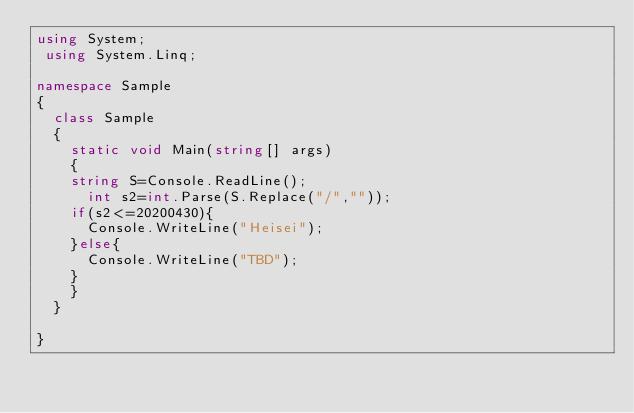Convert code to text. <code><loc_0><loc_0><loc_500><loc_500><_C#_>using System;
 using System.Linq;

namespace Sample
{
  class Sample
  {
    static void Main(string[] args)
    {
    string S=Console.ReadLine();
      int s2=int.Parse(S.Replace("/",""));
    if(s2<=20200430){
      Console.WriteLine("Heisei");
    }else{
      Console.WriteLine("TBD");
    }
    }
  }

}</code> 